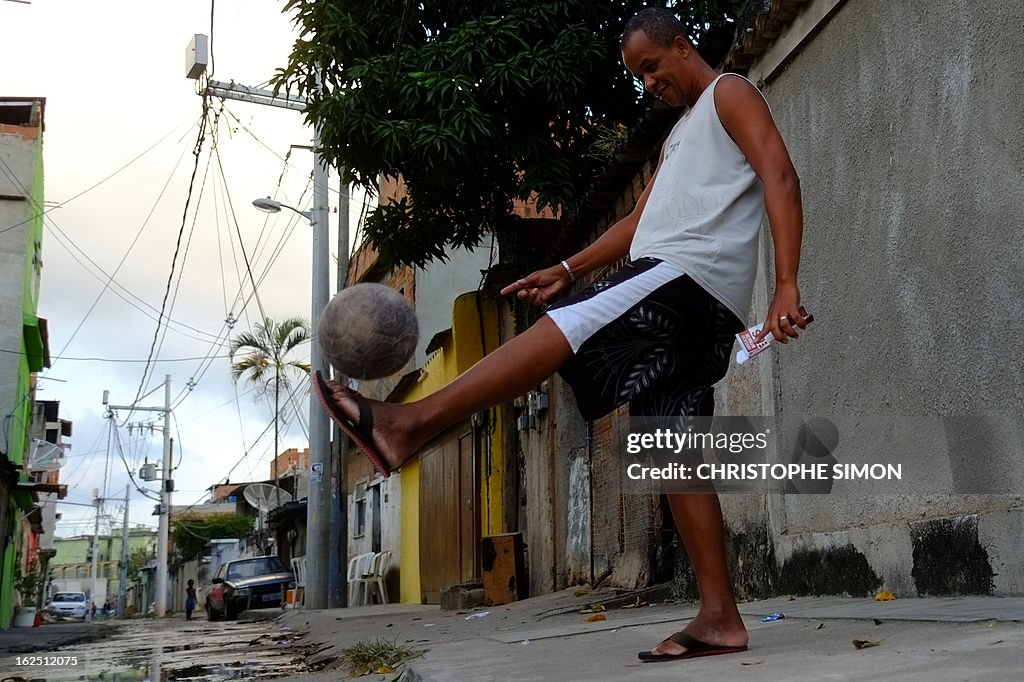How might playing soccer in such an informal setting affect the technique or skills of players like the one shown? Playing in informal, often constrained environments like street settings can significantly develop a player's agility, creativity, and ball handling skills. The need to maneuver in limited spaces, avoid obstacles, and adapt to uneven surfaces can enhance quick thinking and precision. Such conditions breed players who are not only technically proficient but also highly adaptable and strategic in their gameplay. 